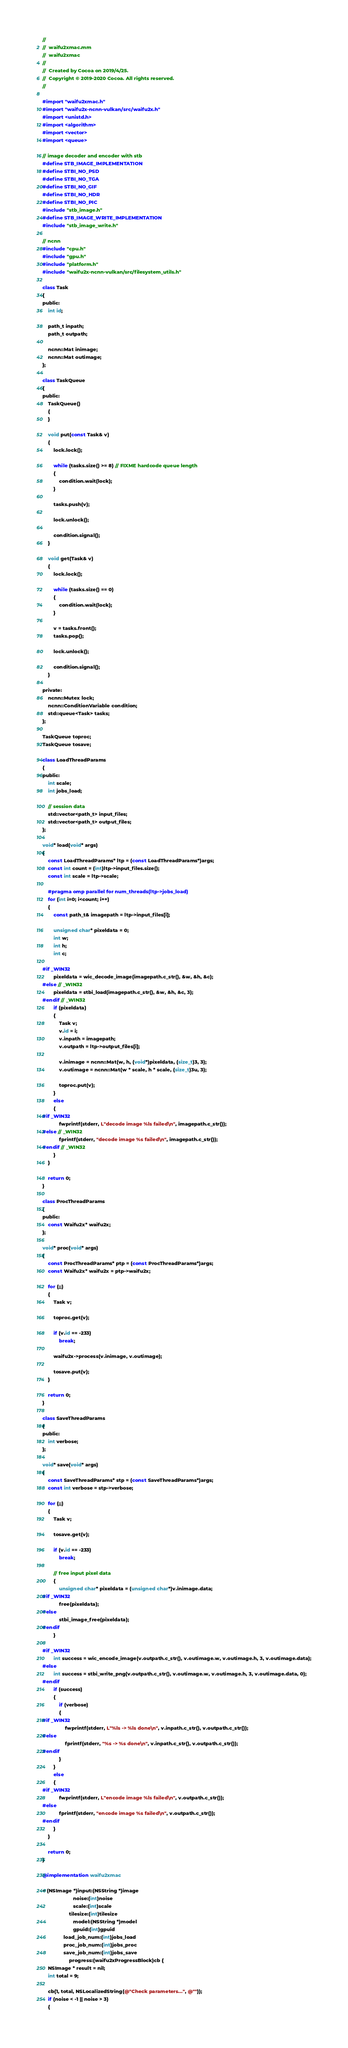Convert code to text. <code><loc_0><loc_0><loc_500><loc_500><_ObjectiveC_>//
//  waifu2xmac.mm
//  waifu2xmac
//
//  Created by Cocoa on 2019/4/25.
//  Copyright © 2019-2020 Cocoa. All rights reserved.
//

#import "waifu2xmac.h"
#import "waifu2x-ncnn-vulkan/src/waifu2x.h"
#import <unistd.h>
#import <algorithm>
#import <vector>
#import <queue>

// image decoder and encoder with stb
#define STB_IMAGE_IMPLEMENTATION
#define STBI_NO_PSD
#define STBI_NO_TGA
#define STBI_NO_GIF
#define STBI_NO_HDR
#define STBI_NO_PIC
#include "stb_image.h"
#define STB_IMAGE_WRITE_IMPLEMENTATION
#include "stb_image_write.h"

// ncnn
#include "cpu.h"
#include "gpu.h"
#include "platform.h"
#include "waifu2x-ncnn-vulkan/src/filesystem_utils.h"

class Task
{
public:
    int id;

    path_t inpath;
    path_t outpath;

    ncnn::Mat inimage;
    ncnn::Mat outimage;
};

class TaskQueue
{
public:
    TaskQueue()
    {
    }

    void put(const Task& v)
    {
        lock.lock();

        while (tasks.size() >= 8) // FIXME hardcode queue length
        {
            condition.wait(lock);
        }

        tasks.push(v);

        lock.unlock();

        condition.signal();
    }

    void get(Task& v)
    {
        lock.lock();

        while (tasks.size() == 0)
        {
            condition.wait(lock);
        }

        v = tasks.front();
        tasks.pop();

        lock.unlock();

        condition.signal();
    }

private:
    ncnn::Mutex lock;
    ncnn::ConditionVariable condition;
    std::queue<Task> tasks;
};

TaskQueue toproc;
TaskQueue tosave;

class LoadThreadParams
{
public:
    int scale;
    int jobs_load;

    // session data
    std::vector<path_t> input_files;
    std::vector<path_t> output_files;
};

void* load(void* args)
{
    const LoadThreadParams* ltp = (const LoadThreadParams*)args;
    const int count = (int)ltp->input_files.size();
    const int scale = ltp->scale;

    #pragma omp parallel for num_threads(ltp->jobs_load)
    for (int i=0; i<count; i++)
    {
        const path_t& imagepath = ltp->input_files[i];

        unsigned char* pixeldata = 0;
        int w;
        int h;
        int c;

#if _WIN32
        pixeldata = wic_decode_image(imagepath.c_str(), &w, &h, &c);
#else // _WIN32
        pixeldata = stbi_load(imagepath.c_str(), &w, &h, &c, 3);
#endif // _WIN32
        if (pixeldata)
        {
            Task v;
            v.id = i;
            v.inpath = imagepath;
            v.outpath = ltp->output_files[i];

            v.inimage = ncnn::Mat(w, h, (void*)pixeldata, (size_t)3, 3);
            v.outimage = ncnn::Mat(w * scale, h * scale, (size_t)3u, 3);

            toproc.put(v);
        }
        else
        {
#if _WIN32
            fwprintf(stderr, L"decode image %ls failed\n", imagepath.c_str());
#else // _WIN32
            fprintf(stderr, "decode image %s failed\n", imagepath.c_str());
#endif // _WIN32
        }
    }

    return 0;
}

class ProcThreadParams
{
public:
    const Waifu2x* waifu2x;
};

void* proc(void* args)
{
    const ProcThreadParams* ptp = (const ProcThreadParams*)args;
    const Waifu2x* waifu2x = ptp->waifu2x;

    for (;;)
    {
        Task v;

        toproc.get(v);

        if (v.id == -233)
            break;

        waifu2x->process(v.inimage, v.outimage);

        tosave.put(v);
    }

    return 0;
}

class SaveThreadParams
{
public:
    int verbose;
};

void* save(void* args)
{
    const SaveThreadParams* stp = (const SaveThreadParams*)args;
    const int verbose = stp->verbose;

    for (;;)
    {
        Task v;

        tosave.get(v);

        if (v.id == -233)
            break;

        // free input pixel data
        {
            unsigned char* pixeldata = (unsigned char*)v.inimage.data;
#if _WIN32
            free(pixeldata);
#else
            stbi_image_free(pixeldata);
#endif
        }

#if _WIN32
        int success = wic_encode_image(v.outpath.c_str(), v.outimage.w, v.outimage.h, 3, v.outimage.data);
#else
        int success = stbi_write_png(v.outpath.c_str(), v.outimage.w, v.outimage.h, 3, v.outimage.data, 0);
#endif
        if (success)
        {
            if (verbose)
            {
#if _WIN32
                fwprintf(stderr, L"%ls -> %ls done\n", v.inpath.c_str(), v.outpath.c_str());
#else
                fprintf(stderr, "%s -> %s done\n", v.inpath.c_str(), v.outpath.c_str());
#endif
            }
        }
        else
        {
#if _WIN32
            fwprintf(stderr, L"encode image %ls failed\n", v.outpath.c_str());
#else
            fprintf(stderr, "encode image %s failed\n", v.outpath.c_str());
#endif
        }
    }

    return 0;
}

@implementation waifu2xmac

+ (NSImage *)input:(NSString *)image
                      noise:(int)noise
                      scale:(int)scale
                   tilesize:(int)tilesize
                      model:(NSString *)model
                      gpuid:(int)gpuid
               load_job_num:(int)jobs_load
               proc_job_num:(int)jobs_proc
               save_job_num:(int)jobs_save
                   progress:(waifu2xProgressBlock)cb {
    NSImage * result = nil;
    int total = 9;
    
    cb(1, total, NSLocalizedString(@"Check parameters...", @""));
    if (noise < -1 || noise > 3)
    {</code> 